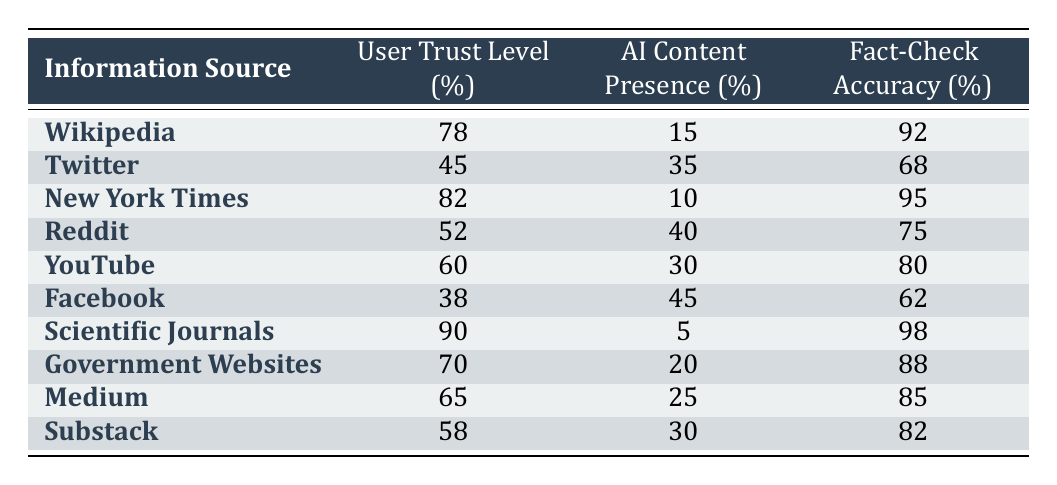What is the User Trust Level for Wikipedia? The User Trust Level for Wikipedia is directly provided in the table under the respective column. It states that the trust level is 78%.
Answer: 78% Which source has the highest Fact-Check Accuracy? To find the highest Fact-Check Accuracy, I look for the maximum value in the 'Fact-Check Accuracy (%)' column. The highest value listed is 98%, which corresponds to Scientific Journals.
Answer: 98% Is the User Trust Level for Facebook higher than that for Reddit? From the table, the User Trust Level for Facebook is 38% and for Reddit is 52%. Since 38% is less than 52%, the statement is false.
Answer: No What is the average User Trust Level of the sources listed? First, I add up all the User Trust Levels: 78 + 45 + 82 + 52 + 60 + 38 + 90 + 70 + 65 + 58 = 758. There are 10 sources, so I divide by 10 to find the average: 758 / 10 = 75.8.
Answer: 75.8 How many sources have AI Content Presence above 30%? The table shows sources and their AI Content Presence percentages. The sources with more than 30% are Twitter (35%), Reddit (40%), YouTube (30%), and Facebook (45%). There are 4 sources that meet this criterion.
Answer: 4 Which source has the lowest AI Content Presence? Looking through the table, the lowest value in the 'AI Content Presence (%)' column is 5%, which corresponds to Scientific Journals.
Answer: 5% What is the difference in Fact-Check Accuracy between Wikipedia and Facebook? The Fact-Check Accuracy for Wikipedia is 92% and for Facebook is 62%. To calculate the difference, I subtract Facebook's accuracy from Wikipedia's: 92 - 62 = 30%.
Answer: 30% Which information source has both high User Trust Level and low AI Content Presence? High User Trust Level could be considered as above 70%, and low AI Content Presence as below 20%. From the table, Scientific Journals fits this criterion with a trust level of 90% and AI presence of 5%.
Answer: Scientific Journals 